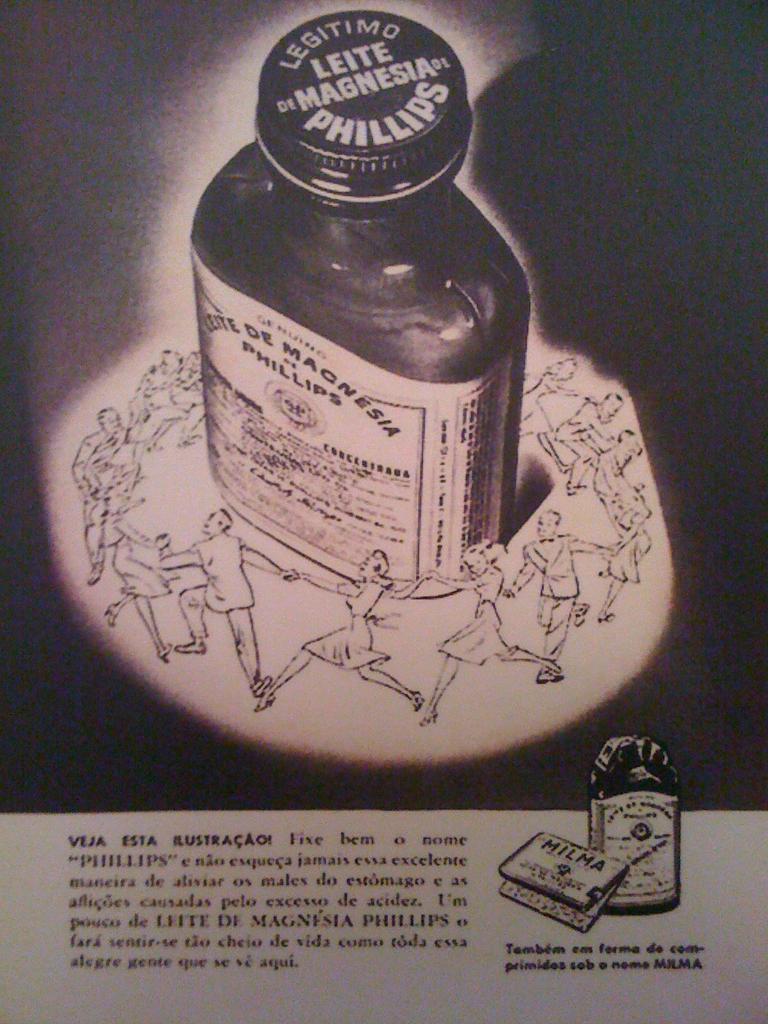What is on the cap of the bottle?
Keep it short and to the point. Phillips. This is bottle?
Provide a succinct answer. Answering does not require reading text in the image. 